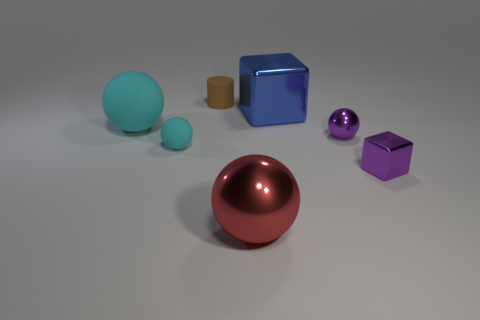There is another matte sphere that is the same color as the tiny rubber sphere; what is its size?
Offer a terse response. Large. How many tiny things are either gray metal cylinders or spheres?
Your answer should be compact. 2. What number of big red metallic spheres are there?
Keep it short and to the point. 1. Is the number of small purple metal spheres behind the large blue metal block the same as the number of big rubber things that are behind the cylinder?
Give a very brief answer. Yes. Are there any brown cylinders behind the cylinder?
Offer a very short reply. No. The big thing left of the small brown cylinder is what color?
Provide a short and direct response. Cyan. There is a large thing behind the big thing that is to the left of the large red metallic thing; what is it made of?
Keep it short and to the point. Metal. Are there fewer tiny purple metallic objects that are behind the brown matte thing than red things right of the big red metal ball?
Give a very brief answer. No. What number of purple objects are either big cubes or metallic objects?
Offer a terse response. 2. Are there an equal number of large cyan rubber things that are to the right of the small brown rubber object and red metallic balls?
Provide a short and direct response. No. 